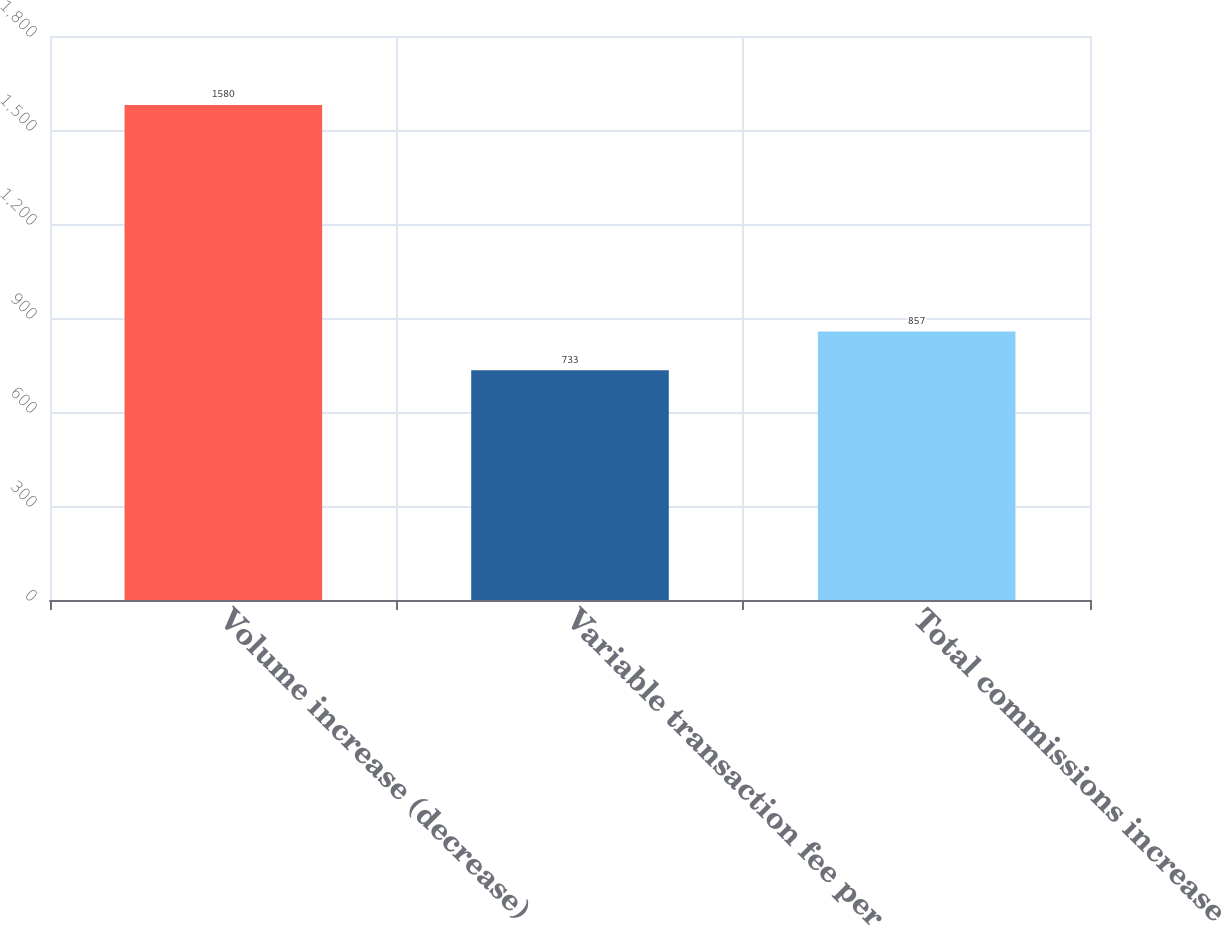<chart> <loc_0><loc_0><loc_500><loc_500><bar_chart><fcel>Volume increase (decrease)<fcel>Variable transaction fee per<fcel>Total commissions increase<nl><fcel>1580<fcel>733<fcel>857<nl></chart> 